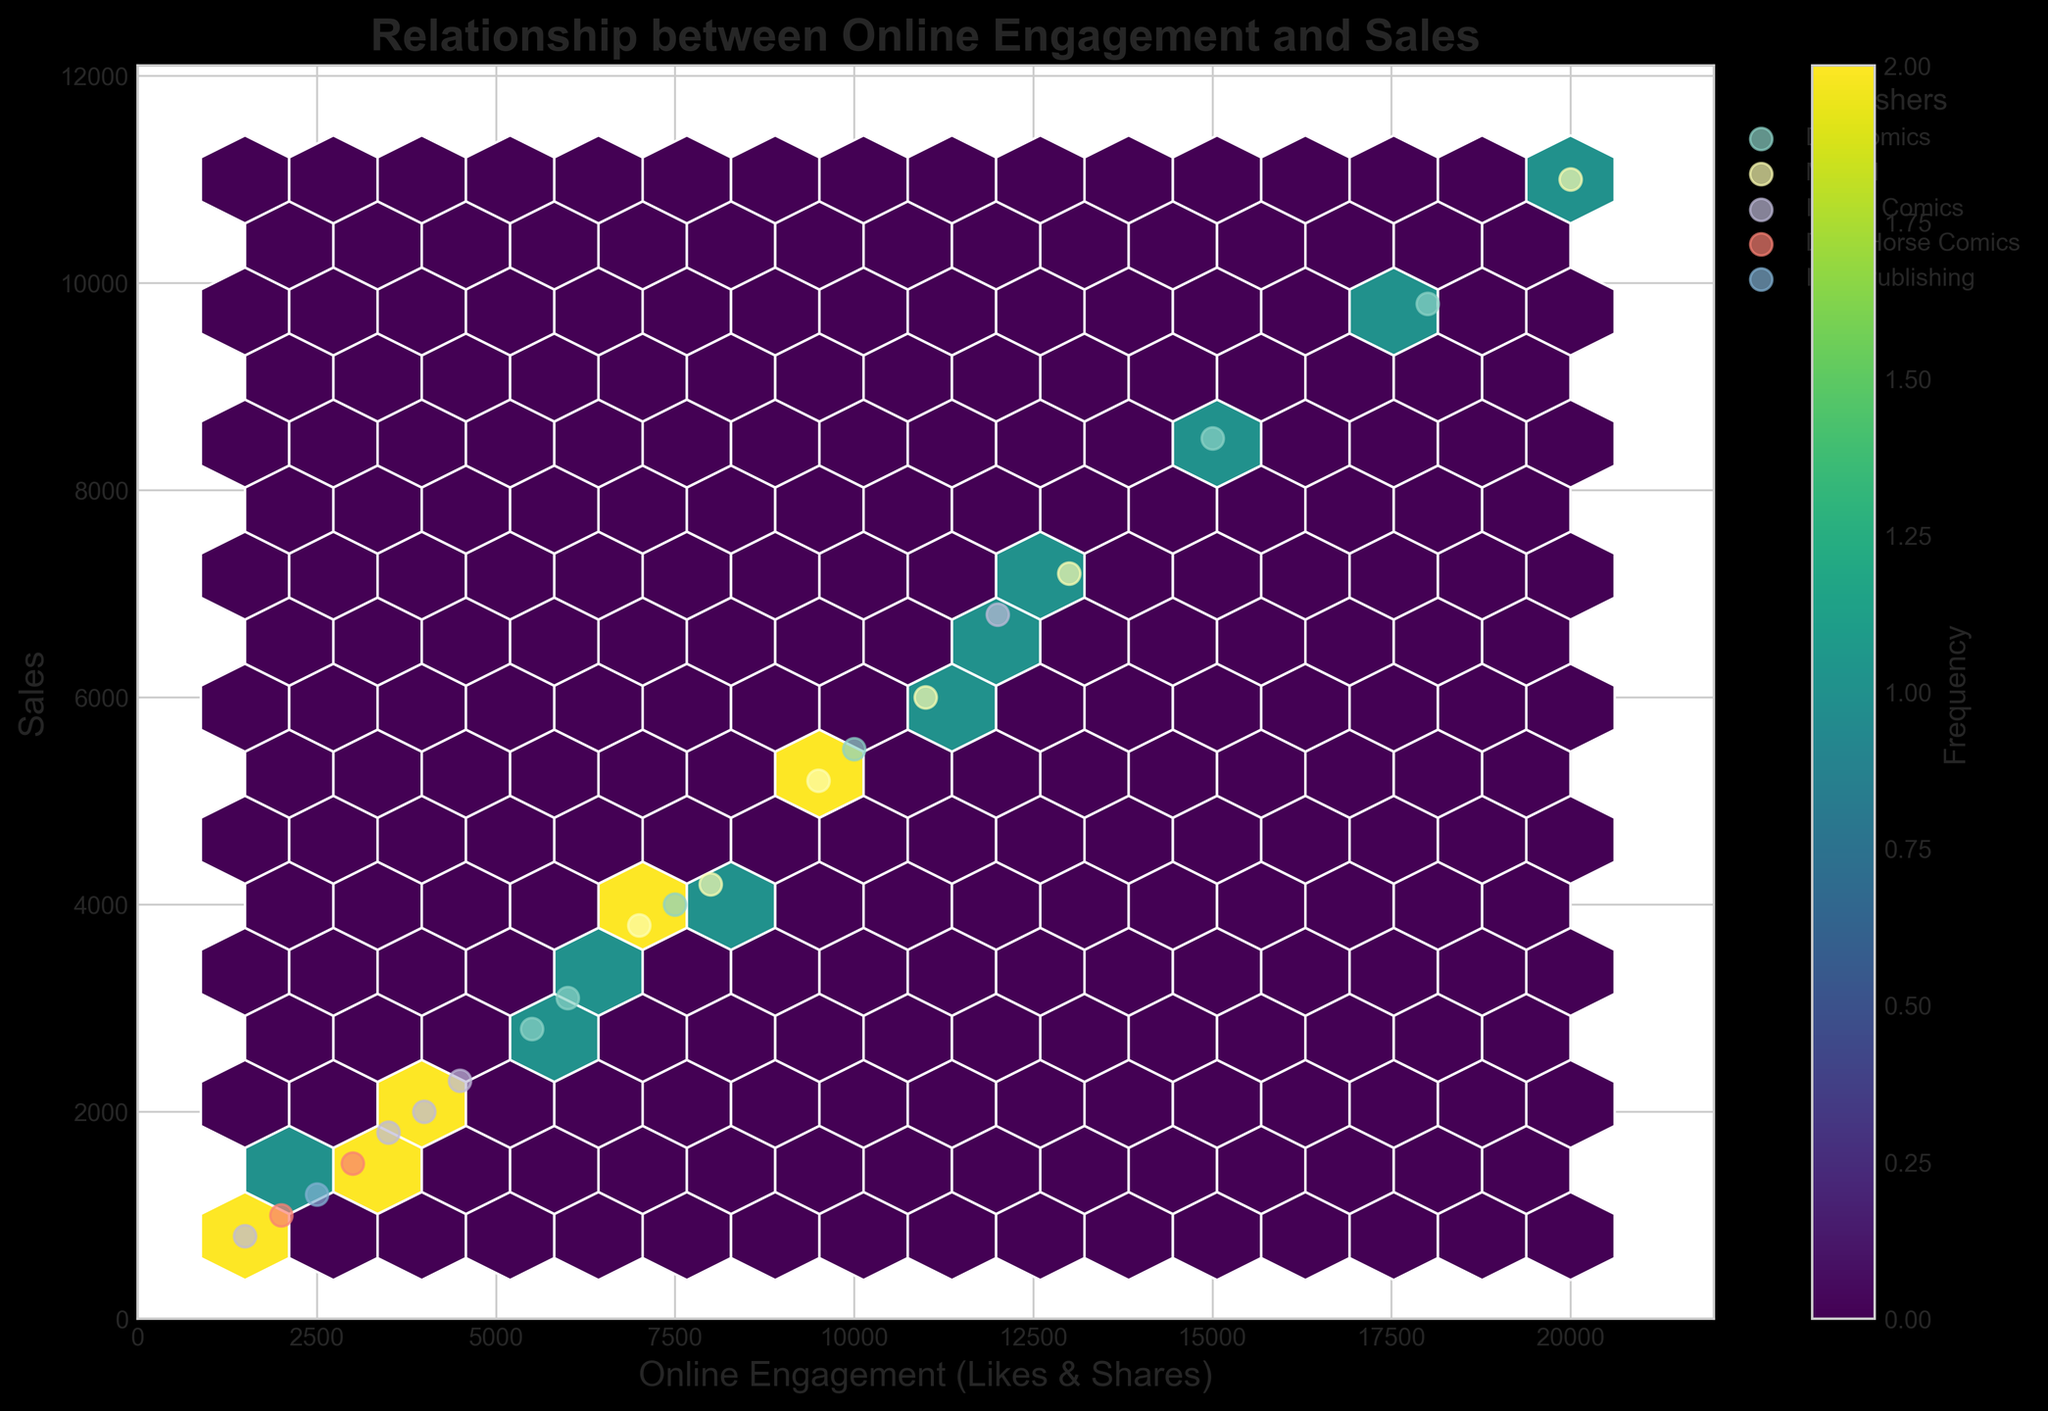What is the title of the hexbin plot? The title is typically found at the very top or center of a plot, so by observing the plot, we can read the title directly.
Answer: Relationship between Online Engagement and Sales What are the labels of the x and y axes in the plot? The labels for the axes are generally displayed along the corresponding axis, x-axis at the bottom and y-axis at the left. We can read these labels from the plot.
Answer: Online Engagement (Likes & Shares), Sales Which publisher appears to have the highest online engagement? We can determine this by observing the scatter points representing online engagement for each publisher. The publisher with the point furthest along the x-axis has the highest engagement.
Answer: Marvel Which data point represents Batman? Batman's data point can be found by identifying the label "Batman" in the scatter plot. Cross-reference its coordinates with the data table to identify the exact data point.
Answer: (15000, 8500) How does the online engagement of "Detective Comics" compare with "X-Men"? We need to find the x-axis values for "Detective Comics" and "X-Men" and compare them.
Answer: Detective Comics has higher online engagement than X-Men What is the frequency of the most populated hexbin? The colorbar on the plot shows the frequency distribution. The brightest color represents the highest frequency. We can match this with the values on the colorbar.
Answer: 2 What is the relationship between online engagement and sales according to the hexbin plot? By observing the overall distribution and trend of the hexbin plot, we can infer that higher online engagement generally correlates with higher sales.
Answer: Positive correlation Which publisher has the most clustered data points in terms of online engagement and sales? By observing the concentration of scatter points, we can determine which publisher has points more closely grouped together.
Answer: DC Comics What is the range of sales values depicted on the y-axis? We can determine the range by looking at the minimum and maximum values along the y-axis.
Answer: 0 to approximately 12000 How many publishers are represented in the plot? Each unique color and marker style can represent different publishers. By referencing the legend, we can count the total number.
Answer: 5 